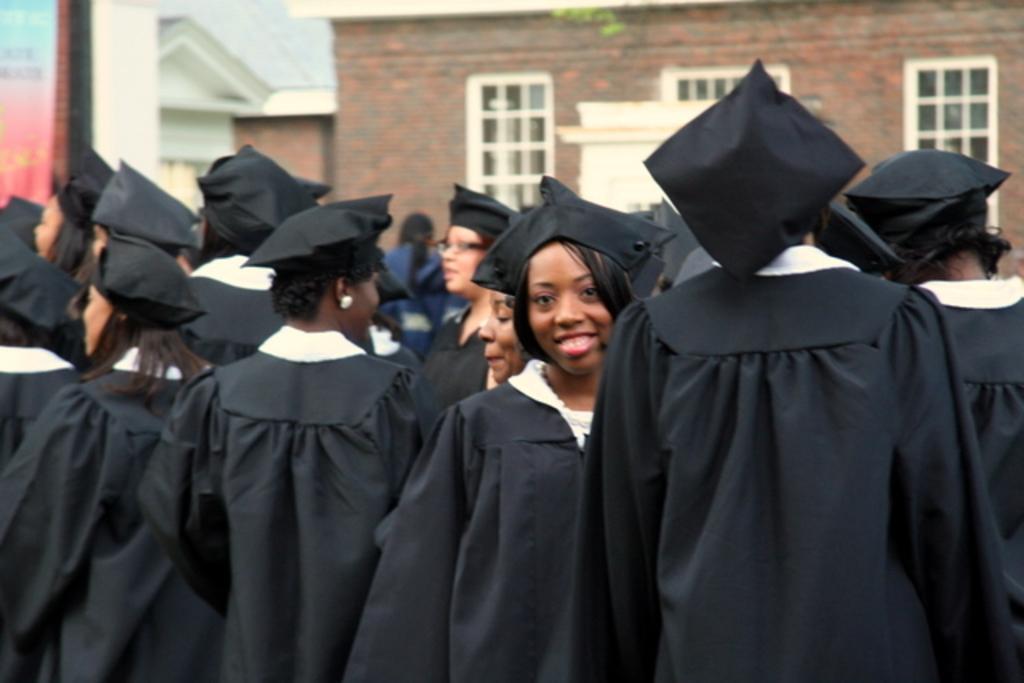Could you give a brief overview of what you see in this image? In this picture there are group of people. In the foreground there is a woman standing and smiling. At the back there is a building and there is a board, there is text on the board. 